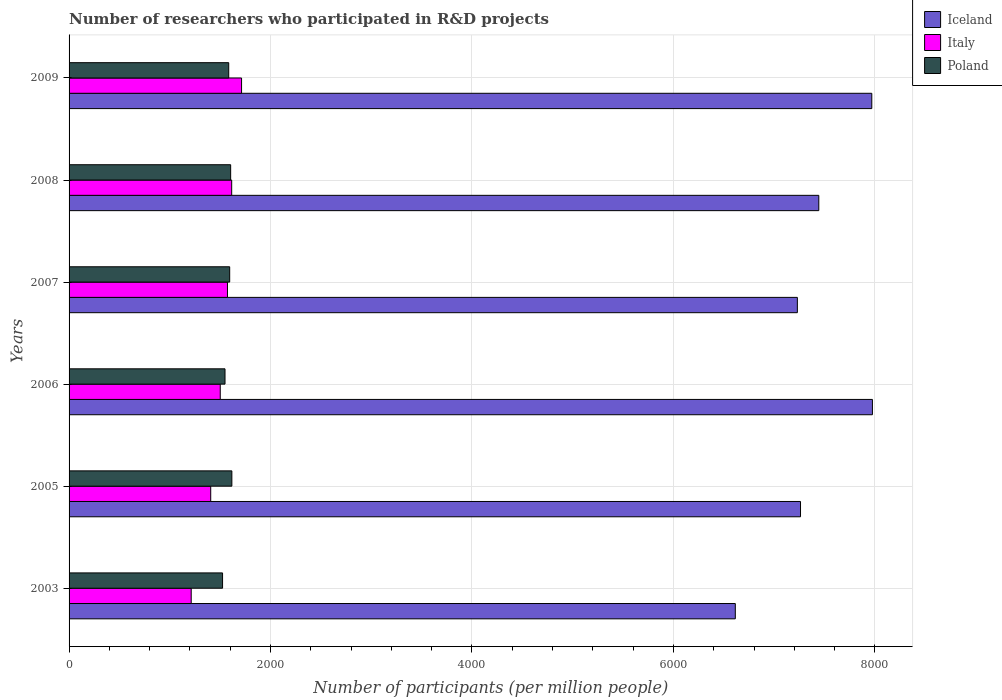How many groups of bars are there?
Provide a succinct answer. 6. Are the number of bars per tick equal to the number of legend labels?
Your response must be concise. Yes. Are the number of bars on each tick of the Y-axis equal?
Your answer should be very brief. Yes. How many bars are there on the 4th tick from the bottom?
Make the answer very short. 3. What is the label of the 6th group of bars from the top?
Offer a very short reply. 2003. What is the number of researchers who participated in R&D projects in Poland in 2007?
Make the answer very short. 1594.67. Across all years, what is the maximum number of researchers who participated in R&D projects in Italy?
Keep it short and to the point. 1712.54. Across all years, what is the minimum number of researchers who participated in R&D projects in Poland?
Your answer should be very brief. 1523.88. In which year was the number of researchers who participated in R&D projects in Italy maximum?
Provide a succinct answer. 2009. In which year was the number of researchers who participated in R&D projects in Italy minimum?
Keep it short and to the point. 2003. What is the total number of researchers who participated in R&D projects in Italy in the graph?
Make the answer very short. 9019.29. What is the difference between the number of researchers who participated in R&D projects in Italy in 2003 and that in 2005?
Your answer should be very brief. -193.7. What is the difference between the number of researchers who participated in R&D projects in Poland in 2005 and the number of researchers who participated in R&D projects in Iceland in 2007?
Provide a succinct answer. -5614.36. What is the average number of researchers who participated in R&D projects in Iceland per year?
Make the answer very short. 7415.85. In the year 2008, what is the difference between the number of researchers who participated in R&D projects in Italy and number of researchers who participated in R&D projects in Iceland?
Provide a succinct answer. -5828.89. What is the ratio of the number of researchers who participated in R&D projects in Italy in 2006 to that in 2009?
Make the answer very short. 0.88. Is the number of researchers who participated in R&D projects in Poland in 2003 less than that in 2006?
Your response must be concise. Yes. Is the difference between the number of researchers who participated in R&D projects in Italy in 2006 and 2008 greater than the difference between the number of researchers who participated in R&D projects in Iceland in 2006 and 2008?
Offer a very short reply. No. What is the difference between the highest and the second highest number of researchers who participated in R&D projects in Iceland?
Ensure brevity in your answer.  6.12. What is the difference between the highest and the lowest number of researchers who participated in R&D projects in Italy?
Provide a short and direct response. 499.96. Is the sum of the number of researchers who participated in R&D projects in Italy in 2003 and 2008 greater than the maximum number of researchers who participated in R&D projects in Iceland across all years?
Offer a terse response. No. What does the 2nd bar from the top in 2009 represents?
Give a very brief answer. Italy. What does the 1st bar from the bottom in 2005 represents?
Your response must be concise. Iceland. How many years are there in the graph?
Offer a very short reply. 6. What is the difference between two consecutive major ticks on the X-axis?
Give a very brief answer. 2000. Does the graph contain any zero values?
Offer a terse response. No. Does the graph contain grids?
Your answer should be compact. Yes. What is the title of the graph?
Keep it short and to the point. Number of researchers who participated in R&D projects. What is the label or title of the X-axis?
Offer a very short reply. Number of participants (per million people). What is the label or title of the Y-axis?
Your response must be concise. Years. What is the Number of participants (per million people) in Iceland in 2003?
Keep it short and to the point. 6614.36. What is the Number of participants (per million people) in Italy in 2003?
Provide a short and direct response. 1212.58. What is the Number of participants (per million people) in Poland in 2003?
Your answer should be compact. 1523.88. What is the Number of participants (per million people) in Iceland in 2005?
Provide a succinct answer. 7261.79. What is the Number of participants (per million people) of Italy in 2005?
Your answer should be very brief. 1406.28. What is the Number of participants (per million people) in Poland in 2005?
Your answer should be very brief. 1616.13. What is the Number of participants (per million people) of Iceland in 2006?
Offer a very short reply. 7975.62. What is the Number of participants (per million people) of Italy in 2006?
Offer a very short reply. 1500.88. What is the Number of participants (per million people) in Poland in 2006?
Provide a short and direct response. 1548.2. What is the Number of participants (per million people) in Iceland in 2007?
Keep it short and to the point. 7230.49. What is the Number of participants (per million people) in Italy in 2007?
Ensure brevity in your answer.  1572.58. What is the Number of participants (per million people) of Poland in 2007?
Your answer should be very brief. 1594.67. What is the Number of participants (per million people) of Iceland in 2008?
Offer a very short reply. 7443.32. What is the Number of participants (per million people) of Italy in 2008?
Ensure brevity in your answer.  1614.42. What is the Number of participants (per million people) of Poland in 2008?
Make the answer very short. 1604.26. What is the Number of participants (per million people) of Iceland in 2009?
Provide a short and direct response. 7969.5. What is the Number of participants (per million people) of Italy in 2009?
Your answer should be very brief. 1712.54. What is the Number of participants (per million people) in Poland in 2009?
Your answer should be compact. 1585.02. Across all years, what is the maximum Number of participants (per million people) in Iceland?
Provide a succinct answer. 7975.62. Across all years, what is the maximum Number of participants (per million people) of Italy?
Your answer should be compact. 1712.54. Across all years, what is the maximum Number of participants (per million people) in Poland?
Your answer should be very brief. 1616.13. Across all years, what is the minimum Number of participants (per million people) in Iceland?
Offer a terse response. 6614.36. Across all years, what is the minimum Number of participants (per million people) of Italy?
Give a very brief answer. 1212.58. Across all years, what is the minimum Number of participants (per million people) in Poland?
Provide a short and direct response. 1523.88. What is the total Number of participants (per million people) of Iceland in the graph?
Your answer should be compact. 4.45e+04. What is the total Number of participants (per million people) in Italy in the graph?
Give a very brief answer. 9019.29. What is the total Number of participants (per million people) in Poland in the graph?
Make the answer very short. 9472.16. What is the difference between the Number of participants (per million people) of Iceland in 2003 and that in 2005?
Keep it short and to the point. -647.43. What is the difference between the Number of participants (per million people) of Italy in 2003 and that in 2005?
Provide a succinct answer. -193.7. What is the difference between the Number of participants (per million people) in Poland in 2003 and that in 2005?
Give a very brief answer. -92.26. What is the difference between the Number of participants (per million people) in Iceland in 2003 and that in 2006?
Keep it short and to the point. -1361.26. What is the difference between the Number of participants (per million people) in Italy in 2003 and that in 2006?
Ensure brevity in your answer.  -288.3. What is the difference between the Number of participants (per million people) in Poland in 2003 and that in 2006?
Provide a short and direct response. -24.32. What is the difference between the Number of participants (per million people) in Iceland in 2003 and that in 2007?
Make the answer very short. -616.13. What is the difference between the Number of participants (per million people) in Italy in 2003 and that in 2007?
Your answer should be compact. -359.99. What is the difference between the Number of participants (per million people) of Poland in 2003 and that in 2007?
Offer a very short reply. -70.79. What is the difference between the Number of participants (per million people) in Iceland in 2003 and that in 2008?
Provide a short and direct response. -828.96. What is the difference between the Number of participants (per million people) in Italy in 2003 and that in 2008?
Ensure brevity in your answer.  -401.84. What is the difference between the Number of participants (per million people) of Poland in 2003 and that in 2008?
Give a very brief answer. -80.38. What is the difference between the Number of participants (per million people) in Iceland in 2003 and that in 2009?
Your answer should be very brief. -1355.14. What is the difference between the Number of participants (per million people) in Italy in 2003 and that in 2009?
Provide a short and direct response. -499.96. What is the difference between the Number of participants (per million people) of Poland in 2003 and that in 2009?
Give a very brief answer. -61.14. What is the difference between the Number of participants (per million people) of Iceland in 2005 and that in 2006?
Provide a succinct answer. -713.83. What is the difference between the Number of participants (per million people) in Italy in 2005 and that in 2006?
Provide a succinct answer. -94.6. What is the difference between the Number of participants (per million people) of Poland in 2005 and that in 2006?
Your response must be concise. 67.94. What is the difference between the Number of participants (per million people) of Iceland in 2005 and that in 2007?
Offer a very short reply. 31.3. What is the difference between the Number of participants (per million people) in Italy in 2005 and that in 2007?
Your answer should be compact. -166.29. What is the difference between the Number of participants (per million people) in Poland in 2005 and that in 2007?
Your answer should be very brief. 21.47. What is the difference between the Number of participants (per million people) in Iceland in 2005 and that in 2008?
Provide a succinct answer. -181.53. What is the difference between the Number of participants (per million people) in Italy in 2005 and that in 2008?
Give a very brief answer. -208.14. What is the difference between the Number of participants (per million people) in Poland in 2005 and that in 2008?
Your answer should be compact. 11.88. What is the difference between the Number of participants (per million people) of Iceland in 2005 and that in 2009?
Provide a succinct answer. -707.71. What is the difference between the Number of participants (per million people) of Italy in 2005 and that in 2009?
Provide a short and direct response. -306.26. What is the difference between the Number of participants (per million people) in Poland in 2005 and that in 2009?
Ensure brevity in your answer.  31.11. What is the difference between the Number of participants (per million people) of Iceland in 2006 and that in 2007?
Provide a succinct answer. 745.13. What is the difference between the Number of participants (per million people) in Italy in 2006 and that in 2007?
Make the answer very short. -71.7. What is the difference between the Number of participants (per million people) in Poland in 2006 and that in 2007?
Your answer should be very brief. -46.47. What is the difference between the Number of participants (per million people) of Iceland in 2006 and that in 2008?
Keep it short and to the point. 532.3. What is the difference between the Number of participants (per million people) of Italy in 2006 and that in 2008?
Keep it short and to the point. -113.54. What is the difference between the Number of participants (per million people) of Poland in 2006 and that in 2008?
Offer a very short reply. -56.06. What is the difference between the Number of participants (per million people) of Iceland in 2006 and that in 2009?
Make the answer very short. 6.12. What is the difference between the Number of participants (per million people) of Italy in 2006 and that in 2009?
Keep it short and to the point. -211.66. What is the difference between the Number of participants (per million people) of Poland in 2006 and that in 2009?
Offer a very short reply. -36.83. What is the difference between the Number of participants (per million people) in Iceland in 2007 and that in 2008?
Offer a very short reply. -212.83. What is the difference between the Number of participants (per million people) of Italy in 2007 and that in 2008?
Keep it short and to the point. -41.84. What is the difference between the Number of participants (per million people) in Poland in 2007 and that in 2008?
Provide a succinct answer. -9.59. What is the difference between the Number of participants (per million people) in Iceland in 2007 and that in 2009?
Keep it short and to the point. -739.01. What is the difference between the Number of participants (per million people) of Italy in 2007 and that in 2009?
Your answer should be compact. -139.97. What is the difference between the Number of participants (per million people) of Poland in 2007 and that in 2009?
Offer a terse response. 9.65. What is the difference between the Number of participants (per million people) in Iceland in 2008 and that in 2009?
Your answer should be compact. -526.18. What is the difference between the Number of participants (per million people) in Italy in 2008 and that in 2009?
Make the answer very short. -98.12. What is the difference between the Number of participants (per million people) of Poland in 2008 and that in 2009?
Provide a succinct answer. 19.23. What is the difference between the Number of participants (per million people) of Iceland in 2003 and the Number of participants (per million people) of Italy in 2005?
Provide a short and direct response. 5208.08. What is the difference between the Number of participants (per million people) in Iceland in 2003 and the Number of participants (per million people) in Poland in 2005?
Ensure brevity in your answer.  4998.22. What is the difference between the Number of participants (per million people) in Italy in 2003 and the Number of participants (per million people) in Poland in 2005?
Keep it short and to the point. -403.55. What is the difference between the Number of participants (per million people) in Iceland in 2003 and the Number of participants (per million people) in Italy in 2006?
Your response must be concise. 5113.48. What is the difference between the Number of participants (per million people) of Iceland in 2003 and the Number of participants (per million people) of Poland in 2006?
Offer a very short reply. 5066.16. What is the difference between the Number of participants (per million people) in Italy in 2003 and the Number of participants (per million people) in Poland in 2006?
Your answer should be compact. -335.61. What is the difference between the Number of participants (per million people) of Iceland in 2003 and the Number of participants (per million people) of Italy in 2007?
Your response must be concise. 5041.78. What is the difference between the Number of participants (per million people) in Iceland in 2003 and the Number of participants (per million people) in Poland in 2007?
Your answer should be very brief. 5019.69. What is the difference between the Number of participants (per million people) of Italy in 2003 and the Number of participants (per million people) of Poland in 2007?
Your response must be concise. -382.08. What is the difference between the Number of participants (per million people) in Iceland in 2003 and the Number of participants (per million people) in Italy in 2008?
Provide a succinct answer. 4999.94. What is the difference between the Number of participants (per million people) of Iceland in 2003 and the Number of participants (per million people) of Poland in 2008?
Offer a very short reply. 5010.1. What is the difference between the Number of participants (per million people) in Italy in 2003 and the Number of participants (per million people) in Poland in 2008?
Make the answer very short. -391.67. What is the difference between the Number of participants (per million people) of Iceland in 2003 and the Number of participants (per million people) of Italy in 2009?
Your answer should be very brief. 4901.81. What is the difference between the Number of participants (per million people) in Iceland in 2003 and the Number of participants (per million people) in Poland in 2009?
Your answer should be very brief. 5029.34. What is the difference between the Number of participants (per million people) of Italy in 2003 and the Number of participants (per million people) of Poland in 2009?
Offer a terse response. -372.44. What is the difference between the Number of participants (per million people) in Iceland in 2005 and the Number of participants (per million people) in Italy in 2006?
Ensure brevity in your answer.  5760.91. What is the difference between the Number of participants (per million people) in Iceland in 2005 and the Number of participants (per million people) in Poland in 2006?
Provide a succinct answer. 5713.59. What is the difference between the Number of participants (per million people) of Italy in 2005 and the Number of participants (per million people) of Poland in 2006?
Offer a very short reply. -141.91. What is the difference between the Number of participants (per million people) in Iceland in 2005 and the Number of participants (per million people) in Italy in 2007?
Provide a short and direct response. 5689.21. What is the difference between the Number of participants (per million people) in Iceland in 2005 and the Number of participants (per million people) in Poland in 2007?
Ensure brevity in your answer.  5667.12. What is the difference between the Number of participants (per million people) of Italy in 2005 and the Number of participants (per million people) of Poland in 2007?
Your answer should be compact. -188.38. What is the difference between the Number of participants (per million people) in Iceland in 2005 and the Number of participants (per million people) in Italy in 2008?
Your answer should be compact. 5647.37. What is the difference between the Number of participants (per million people) in Iceland in 2005 and the Number of participants (per million people) in Poland in 2008?
Ensure brevity in your answer.  5657.53. What is the difference between the Number of participants (per million people) in Italy in 2005 and the Number of participants (per million people) in Poland in 2008?
Offer a very short reply. -197.97. What is the difference between the Number of participants (per million people) in Iceland in 2005 and the Number of participants (per million people) in Italy in 2009?
Your answer should be compact. 5549.25. What is the difference between the Number of participants (per million people) of Iceland in 2005 and the Number of participants (per million people) of Poland in 2009?
Your answer should be compact. 5676.77. What is the difference between the Number of participants (per million people) of Italy in 2005 and the Number of participants (per million people) of Poland in 2009?
Provide a short and direct response. -178.74. What is the difference between the Number of participants (per million people) in Iceland in 2006 and the Number of participants (per million people) in Italy in 2007?
Keep it short and to the point. 6403.04. What is the difference between the Number of participants (per million people) in Iceland in 2006 and the Number of participants (per million people) in Poland in 2007?
Offer a terse response. 6380.95. What is the difference between the Number of participants (per million people) in Italy in 2006 and the Number of participants (per million people) in Poland in 2007?
Your answer should be very brief. -93.79. What is the difference between the Number of participants (per million people) in Iceland in 2006 and the Number of participants (per million people) in Italy in 2008?
Provide a succinct answer. 6361.2. What is the difference between the Number of participants (per million people) of Iceland in 2006 and the Number of participants (per million people) of Poland in 2008?
Your answer should be very brief. 6371.36. What is the difference between the Number of participants (per million people) in Italy in 2006 and the Number of participants (per million people) in Poland in 2008?
Your answer should be very brief. -103.38. What is the difference between the Number of participants (per million people) of Iceland in 2006 and the Number of participants (per million people) of Italy in 2009?
Keep it short and to the point. 6263.07. What is the difference between the Number of participants (per million people) in Iceland in 2006 and the Number of participants (per million people) in Poland in 2009?
Make the answer very short. 6390.6. What is the difference between the Number of participants (per million people) of Italy in 2006 and the Number of participants (per million people) of Poland in 2009?
Provide a short and direct response. -84.14. What is the difference between the Number of participants (per million people) in Iceland in 2007 and the Number of participants (per million people) in Italy in 2008?
Give a very brief answer. 5616.07. What is the difference between the Number of participants (per million people) in Iceland in 2007 and the Number of participants (per million people) in Poland in 2008?
Give a very brief answer. 5626.23. What is the difference between the Number of participants (per million people) of Italy in 2007 and the Number of participants (per million people) of Poland in 2008?
Offer a terse response. -31.68. What is the difference between the Number of participants (per million people) of Iceland in 2007 and the Number of participants (per million people) of Italy in 2009?
Your answer should be very brief. 5517.95. What is the difference between the Number of participants (per million people) of Iceland in 2007 and the Number of participants (per million people) of Poland in 2009?
Your response must be concise. 5645.47. What is the difference between the Number of participants (per million people) of Italy in 2007 and the Number of participants (per million people) of Poland in 2009?
Your response must be concise. -12.44. What is the difference between the Number of participants (per million people) in Iceland in 2008 and the Number of participants (per million people) in Italy in 2009?
Your answer should be compact. 5730.77. What is the difference between the Number of participants (per million people) in Iceland in 2008 and the Number of participants (per million people) in Poland in 2009?
Provide a short and direct response. 5858.29. What is the difference between the Number of participants (per million people) in Italy in 2008 and the Number of participants (per million people) in Poland in 2009?
Your answer should be compact. 29.4. What is the average Number of participants (per million people) of Iceland per year?
Provide a short and direct response. 7415.85. What is the average Number of participants (per million people) of Italy per year?
Ensure brevity in your answer.  1503.22. What is the average Number of participants (per million people) in Poland per year?
Your response must be concise. 1578.69. In the year 2003, what is the difference between the Number of participants (per million people) in Iceland and Number of participants (per million people) in Italy?
Your answer should be very brief. 5401.78. In the year 2003, what is the difference between the Number of participants (per million people) in Iceland and Number of participants (per million people) in Poland?
Provide a succinct answer. 5090.48. In the year 2003, what is the difference between the Number of participants (per million people) of Italy and Number of participants (per million people) of Poland?
Your answer should be very brief. -311.29. In the year 2005, what is the difference between the Number of participants (per million people) in Iceland and Number of participants (per million people) in Italy?
Provide a succinct answer. 5855.51. In the year 2005, what is the difference between the Number of participants (per million people) of Iceland and Number of participants (per million people) of Poland?
Make the answer very short. 5645.66. In the year 2005, what is the difference between the Number of participants (per million people) of Italy and Number of participants (per million people) of Poland?
Offer a very short reply. -209.85. In the year 2006, what is the difference between the Number of participants (per million people) in Iceland and Number of participants (per million people) in Italy?
Make the answer very short. 6474.74. In the year 2006, what is the difference between the Number of participants (per million people) in Iceland and Number of participants (per million people) in Poland?
Give a very brief answer. 6427.42. In the year 2006, what is the difference between the Number of participants (per million people) of Italy and Number of participants (per million people) of Poland?
Provide a short and direct response. -47.32. In the year 2007, what is the difference between the Number of participants (per million people) of Iceland and Number of participants (per million people) of Italy?
Offer a very short reply. 5657.91. In the year 2007, what is the difference between the Number of participants (per million people) of Iceland and Number of participants (per million people) of Poland?
Provide a succinct answer. 5635.82. In the year 2007, what is the difference between the Number of participants (per million people) of Italy and Number of participants (per million people) of Poland?
Provide a short and direct response. -22.09. In the year 2008, what is the difference between the Number of participants (per million people) in Iceland and Number of participants (per million people) in Italy?
Provide a short and direct response. 5828.89. In the year 2008, what is the difference between the Number of participants (per million people) of Iceland and Number of participants (per million people) of Poland?
Keep it short and to the point. 5839.06. In the year 2008, what is the difference between the Number of participants (per million people) in Italy and Number of participants (per million people) in Poland?
Offer a terse response. 10.17. In the year 2009, what is the difference between the Number of participants (per million people) of Iceland and Number of participants (per million people) of Italy?
Make the answer very short. 6256.95. In the year 2009, what is the difference between the Number of participants (per million people) in Iceland and Number of participants (per million people) in Poland?
Your answer should be compact. 6384.47. In the year 2009, what is the difference between the Number of participants (per million people) of Italy and Number of participants (per million people) of Poland?
Provide a short and direct response. 127.52. What is the ratio of the Number of participants (per million people) of Iceland in 2003 to that in 2005?
Ensure brevity in your answer.  0.91. What is the ratio of the Number of participants (per million people) in Italy in 2003 to that in 2005?
Ensure brevity in your answer.  0.86. What is the ratio of the Number of participants (per million people) in Poland in 2003 to that in 2005?
Keep it short and to the point. 0.94. What is the ratio of the Number of participants (per million people) in Iceland in 2003 to that in 2006?
Offer a very short reply. 0.83. What is the ratio of the Number of participants (per million people) in Italy in 2003 to that in 2006?
Make the answer very short. 0.81. What is the ratio of the Number of participants (per million people) in Poland in 2003 to that in 2006?
Ensure brevity in your answer.  0.98. What is the ratio of the Number of participants (per million people) of Iceland in 2003 to that in 2007?
Your response must be concise. 0.91. What is the ratio of the Number of participants (per million people) of Italy in 2003 to that in 2007?
Give a very brief answer. 0.77. What is the ratio of the Number of participants (per million people) in Poland in 2003 to that in 2007?
Provide a succinct answer. 0.96. What is the ratio of the Number of participants (per million people) in Iceland in 2003 to that in 2008?
Make the answer very short. 0.89. What is the ratio of the Number of participants (per million people) of Italy in 2003 to that in 2008?
Keep it short and to the point. 0.75. What is the ratio of the Number of participants (per million people) in Poland in 2003 to that in 2008?
Give a very brief answer. 0.95. What is the ratio of the Number of participants (per million people) in Iceland in 2003 to that in 2009?
Offer a terse response. 0.83. What is the ratio of the Number of participants (per million people) of Italy in 2003 to that in 2009?
Your response must be concise. 0.71. What is the ratio of the Number of participants (per million people) of Poland in 2003 to that in 2009?
Your answer should be compact. 0.96. What is the ratio of the Number of participants (per million people) of Iceland in 2005 to that in 2006?
Offer a very short reply. 0.91. What is the ratio of the Number of participants (per million people) in Italy in 2005 to that in 2006?
Give a very brief answer. 0.94. What is the ratio of the Number of participants (per million people) in Poland in 2005 to that in 2006?
Your response must be concise. 1.04. What is the ratio of the Number of participants (per million people) of Italy in 2005 to that in 2007?
Your response must be concise. 0.89. What is the ratio of the Number of participants (per million people) of Poland in 2005 to that in 2007?
Give a very brief answer. 1.01. What is the ratio of the Number of participants (per million people) in Iceland in 2005 to that in 2008?
Give a very brief answer. 0.98. What is the ratio of the Number of participants (per million people) in Italy in 2005 to that in 2008?
Provide a short and direct response. 0.87. What is the ratio of the Number of participants (per million people) in Poland in 2005 to that in 2008?
Offer a very short reply. 1.01. What is the ratio of the Number of participants (per million people) of Iceland in 2005 to that in 2009?
Offer a terse response. 0.91. What is the ratio of the Number of participants (per million people) in Italy in 2005 to that in 2009?
Your answer should be very brief. 0.82. What is the ratio of the Number of participants (per million people) in Poland in 2005 to that in 2009?
Give a very brief answer. 1.02. What is the ratio of the Number of participants (per million people) in Iceland in 2006 to that in 2007?
Offer a very short reply. 1.1. What is the ratio of the Number of participants (per million people) in Italy in 2006 to that in 2007?
Make the answer very short. 0.95. What is the ratio of the Number of participants (per million people) of Poland in 2006 to that in 2007?
Offer a very short reply. 0.97. What is the ratio of the Number of participants (per million people) in Iceland in 2006 to that in 2008?
Offer a terse response. 1.07. What is the ratio of the Number of participants (per million people) in Italy in 2006 to that in 2008?
Offer a very short reply. 0.93. What is the ratio of the Number of participants (per million people) of Poland in 2006 to that in 2008?
Provide a succinct answer. 0.97. What is the ratio of the Number of participants (per million people) in Italy in 2006 to that in 2009?
Your answer should be compact. 0.88. What is the ratio of the Number of participants (per million people) of Poland in 2006 to that in 2009?
Your answer should be very brief. 0.98. What is the ratio of the Number of participants (per million people) in Iceland in 2007 to that in 2008?
Ensure brevity in your answer.  0.97. What is the ratio of the Number of participants (per million people) of Italy in 2007 to that in 2008?
Offer a terse response. 0.97. What is the ratio of the Number of participants (per million people) in Iceland in 2007 to that in 2009?
Offer a terse response. 0.91. What is the ratio of the Number of participants (per million people) of Italy in 2007 to that in 2009?
Offer a very short reply. 0.92. What is the ratio of the Number of participants (per million people) of Iceland in 2008 to that in 2009?
Provide a short and direct response. 0.93. What is the ratio of the Number of participants (per million people) of Italy in 2008 to that in 2009?
Provide a succinct answer. 0.94. What is the ratio of the Number of participants (per million people) of Poland in 2008 to that in 2009?
Offer a very short reply. 1.01. What is the difference between the highest and the second highest Number of participants (per million people) in Iceland?
Your answer should be compact. 6.12. What is the difference between the highest and the second highest Number of participants (per million people) of Italy?
Make the answer very short. 98.12. What is the difference between the highest and the second highest Number of participants (per million people) of Poland?
Keep it short and to the point. 11.88. What is the difference between the highest and the lowest Number of participants (per million people) in Iceland?
Your answer should be compact. 1361.26. What is the difference between the highest and the lowest Number of participants (per million people) of Italy?
Keep it short and to the point. 499.96. What is the difference between the highest and the lowest Number of participants (per million people) of Poland?
Your answer should be compact. 92.26. 